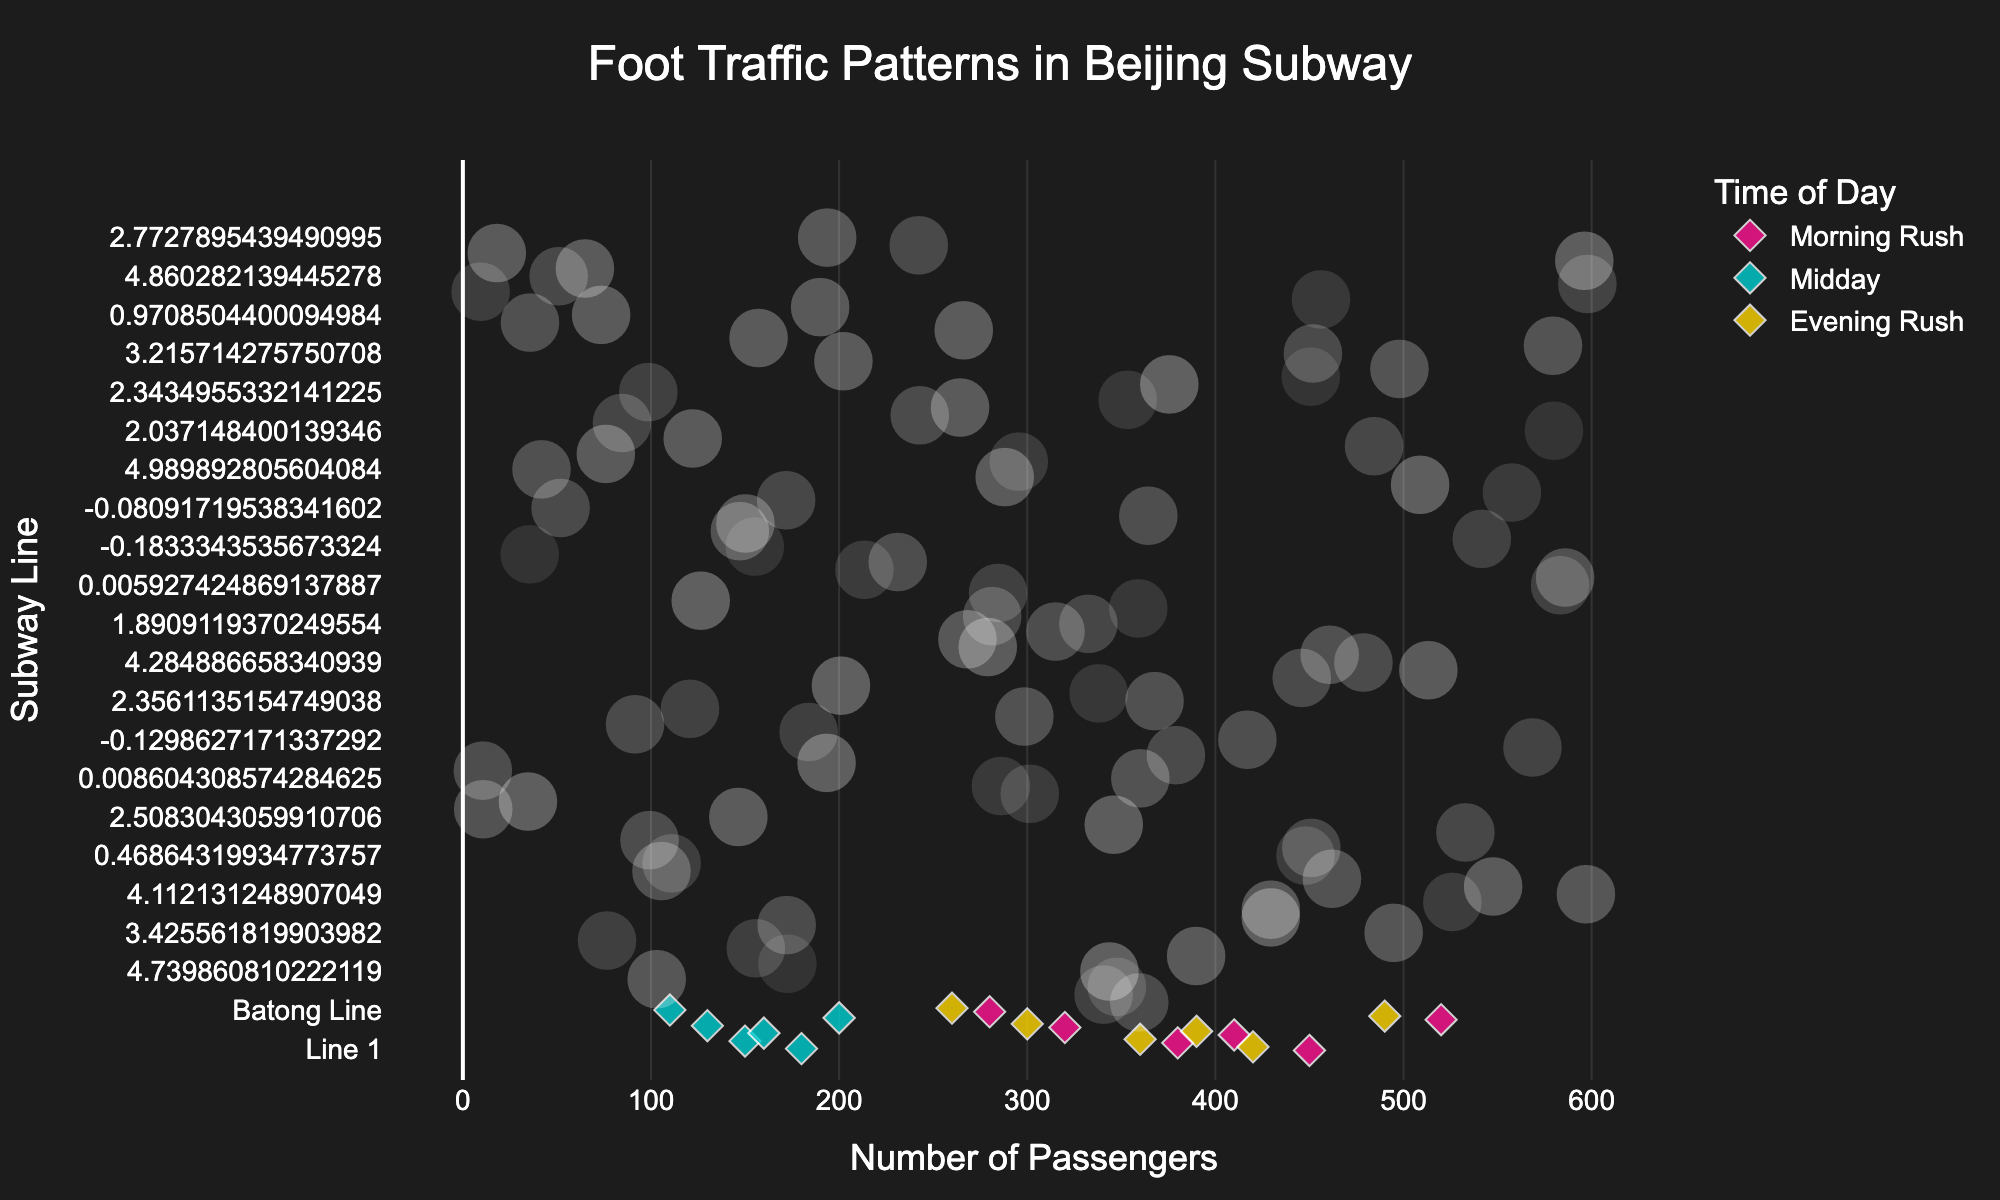Is the number of passengers higher during the morning rush or the midday time for Line 10? To determine which time period has more passengers, compare the number of passengers for Line 10 during the morning rush and midday. According to the data, Line 10 has 520 passengers in the morning rush and 200 passengers at midday, so the morning rush has more passengers.
Answer: Morning Rush Which subway line has the highest number of passengers during the evening rush? Look at the number of passengers for each subway line during the evening rush to find the highest one. According to the data, Line 10 has 490 passengers, which is the highest compared to the other lines during the evening rush.
Answer: Line 10 What's the difference in passenger numbers between the morning rush and the evening rush for Line 1? Subtract the number of passengers for Line 1 during the evening rush from the number during the morning rush: 450 (morning rush) - 420 (evening rush) = 30.
Answer: 30 Which time period has the least foot traffic for Line 5? Compare the number of passengers for Line 5 across different times of the day. According to the data, midday has the least foot traffic with 130 passengers.
Answer: Midday How many total passengers use Line 2 in a day based on the given data? Add the number of passengers for Line 2 during all three times of the day: 380 (morning rush) + 150 (midday) + 360 (evening rush) = 890.
Answer: 890 On which Line does the foot traffic during the morning rush almost equal the foot traffic in the evening rush? Compare the passenger numbers during the morning and evening rush periods for all lines. Line 4 has 410 passengers in the morning rush and 390 in the evening rush, which are closest in value.
Answer: Line 4 What is the average number of passengers on the Batong line throughout the day? Sum up the passengers for all times of the day on the Batong line and divide by the number of time periods: (280 + 110 + 260) / 3 = 650 / 3 ≈ 217.
Answer: 217 Does any line have an equal number of passengers during the morning rush and midday? Compare the passenger numbers for each line between the morning rush and midday. None of the lines have equal passenger numbers for these times.
Answer: No 